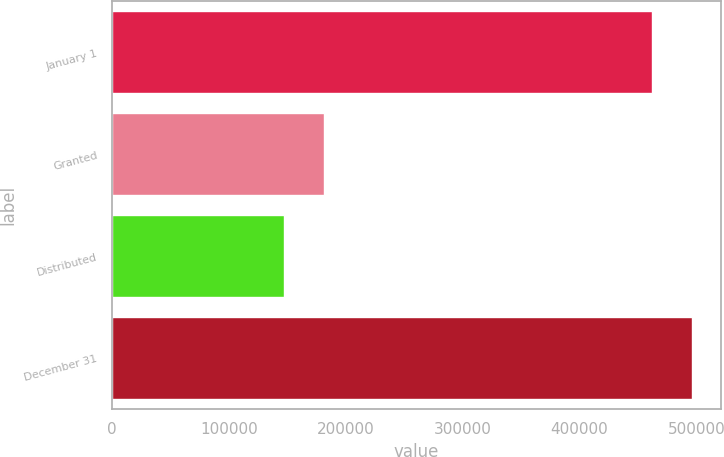<chart> <loc_0><loc_0><loc_500><loc_500><bar_chart><fcel>January 1<fcel>Granted<fcel>Distributed<fcel>December 31<nl><fcel>462381<fcel>181426<fcel>147264<fcel>496543<nl></chart> 